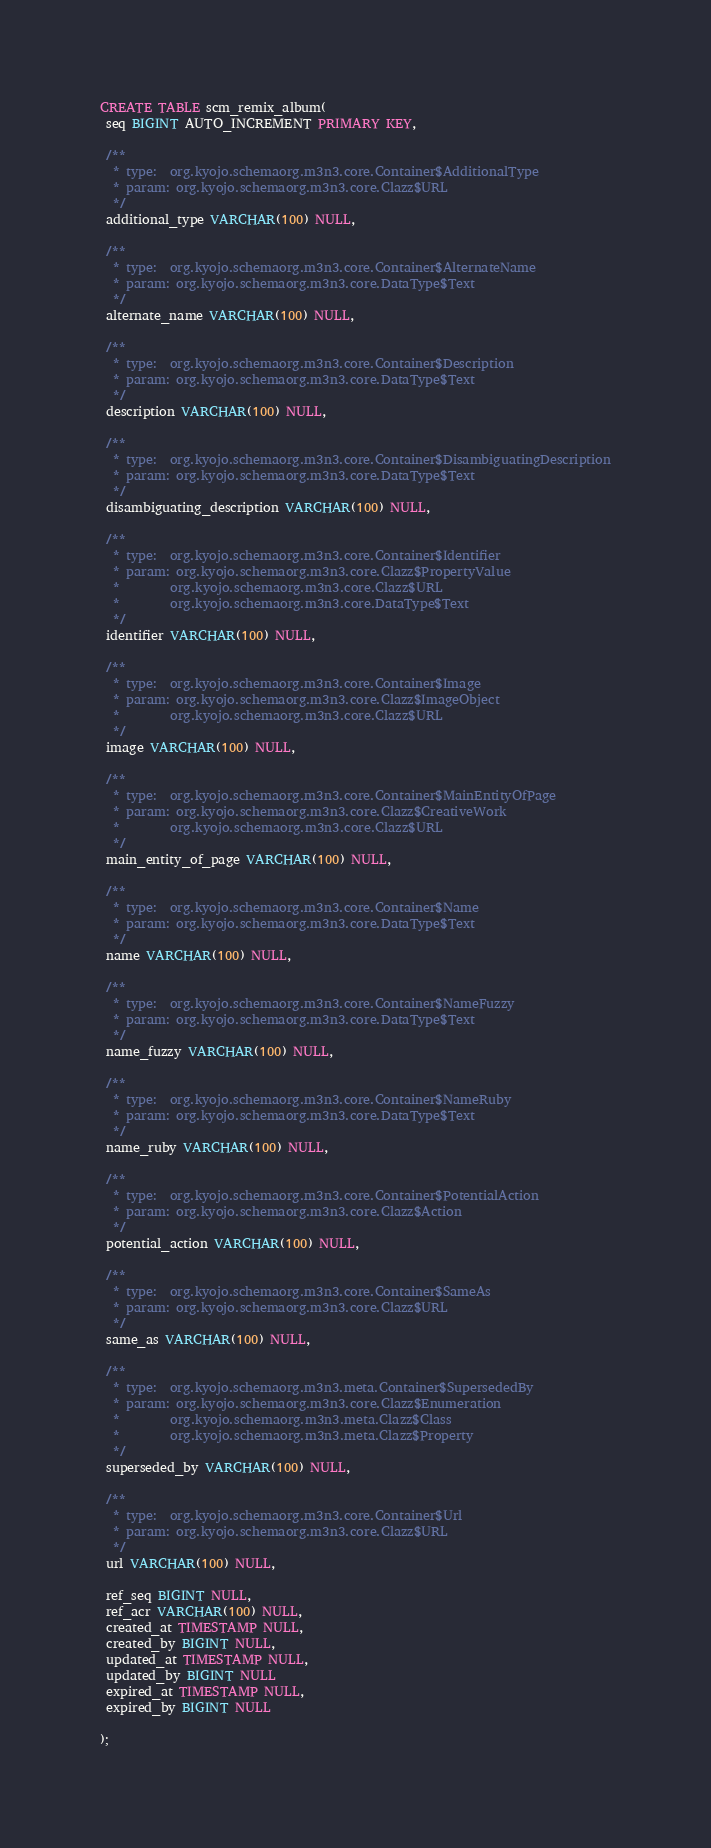<code> <loc_0><loc_0><loc_500><loc_500><_SQL_>CREATE TABLE scm_remix_album(
 seq BIGINT AUTO_INCREMENT PRIMARY KEY,

 /**
  * type:  org.kyojo.schemaorg.m3n3.core.Container$AdditionalType
  * param: org.kyojo.schemaorg.m3n3.core.Clazz$URL
  */
 additional_type VARCHAR(100) NULL,

 /**
  * type:  org.kyojo.schemaorg.m3n3.core.Container$AlternateName
  * param: org.kyojo.schemaorg.m3n3.core.DataType$Text
  */
 alternate_name VARCHAR(100) NULL,

 /**
  * type:  org.kyojo.schemaorg.m3n3.core.Container$Description
  * param: org.kyojo.schemaorg.m3n3.core.DataType$Text
  */
 description VARCHAR(100) NULL,

 /**
  * type:  org.kyojo.schemaorg.m3n3.core.Container$DisambiguatingDescription
  * param: org.kyojo.schemaorg.m3n3.core.DataType$Text
  */
 disambiguating_description VARCHAR(100) NULL,

 /**
  * type:  org.kyojo.schemaorg.m3n3.core.Container$Identifier
  * param: org.kyojo.schemaorg.m3n3.core.Clazz$PropertyValue
  *        org.kyojo.schemaorg.m3n3.core.Clazz$URL
  *        org.kyojo.schemaorg.m3n3.core.DataType$Text
  */
 identifier VARCHAR(100) NULL,

 /**
  * type:  org.kyojo.schemaorg.m3n3.core.Container$Image
  * param: org.kyojo.schemaorg.m3n3.core.Clazz$ImageObject
  *        org.kyojo.schemaorg.m3n3.core.Clazz$URL
  */
 image VARCHAR(100) NULL,

 /**
  * type:  org.kyojo.schemaorg.m3n3.core.Container$MainEntityOfPage
  * param: org.kyojo.schemaorg.m3n3.core.Clazz$CreativeWork
  *        org.kyojo.schemaorg.m3n3.core.Clazz$URL
  */
 main_entity_of_page VARCHAR(100) NULL,

 /**
  * type:  org.kyojo.schemaorg.m3n3.core.Container$Name
  * param: org.kyojo.schemaorg.m3n3.core.DataType$Text
  */
 name VARCHAR(100) NULL,

 /**
  * type:  org.kyojo.schemaorg.m3n3.core.Container$NameFuzzy
  * param: org.kyojo.schemaorg.m3n3.core.DataType$Text
  */
 name_fuzzy VARCHAR(100) NULL,

 /**
  * type:  org.kyojo.schemaorg.m3n3.core.Container$NameRuby
  * param: org.kyojo.schemaorg.m3n3.core.DataType$Text
  */
 name_ruby VARCHAR(100) NULL,

 /**
  * type:  org.kyojo.schemaorg.m3n3.core.Container$PotentialAction
  * param: org.kyojo.schemaorg.m3n3.core.Clazz$Action
  */
 potential_action VARCHAR(100) NULL,

 /**
  * type:  org.kyojo.schemaorg.m3n3.core.Container$SameAs
  * param: org.kyojo.schemaorg.m3n3.core.Clazz$URL
  */
 same_as VARCHAR(100) NULL,

 /**
  * type:  org.kyojo.schemaorg.m3n3.meta.Container$SupersededBy
  * param: org.kyojo.schemaorg.m3n3.core.Clazz$Enumeration
  *        org.kyojo.schemaorg.m3n3.meta.Clazz$Class
  *        org.kyojo.schemaorg.m3n3.meta.Clazz$Property
  */
 superseded_by VARCHAR(100) NULL,

 /**
  * type:  org.kyojo.schemaorg.m3n3.core.Container$Url
  * param: org.kyojo.schemaorg.m3n3.core.Clazz$URL
  */
 url VARCHAR(100) NULL,

 ref_seq BIGINT NULL,
 ref_acr VARCHAR(100) NULL,
 created_at TIMESTAMP NULL,
 created_by BIGINT NULL,
 updated_at TIMESTAMP NULL,
 updated_by BIGINT NULL
 expired_at TIMESTAMP NULL,
 expired_by BIGINT NULL

);</code> 